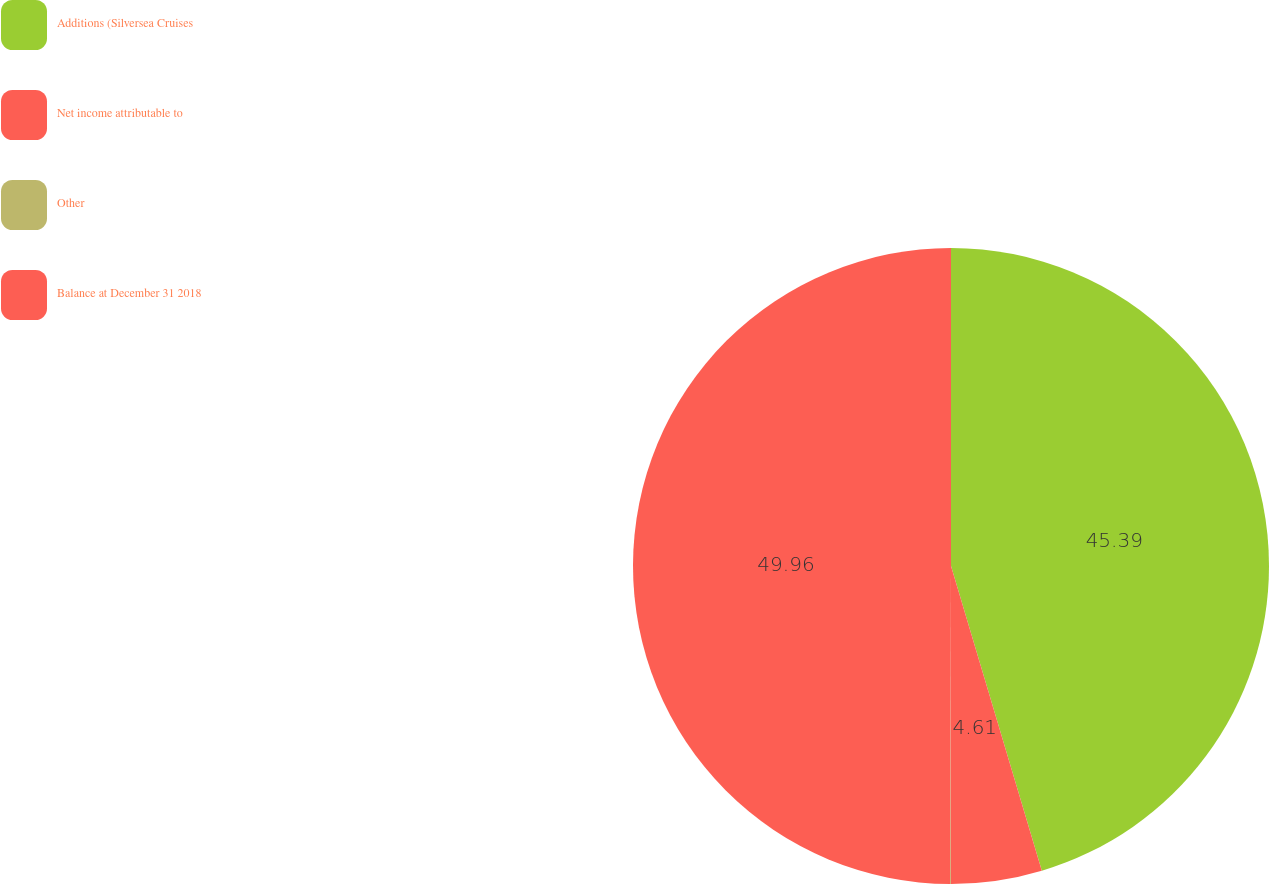<chart> <loc_0><loc_0><loc_500><loc_500><pie_chart><fcel>Additions (Silversea Cruises<fcel>Net income attributable to<fcel>Other<fcel>Balance at December 31 2018<nl><fcel>45.39%<fcel>4.61%<fcel>0.04%<fcel>49.96%<nl></chart> 